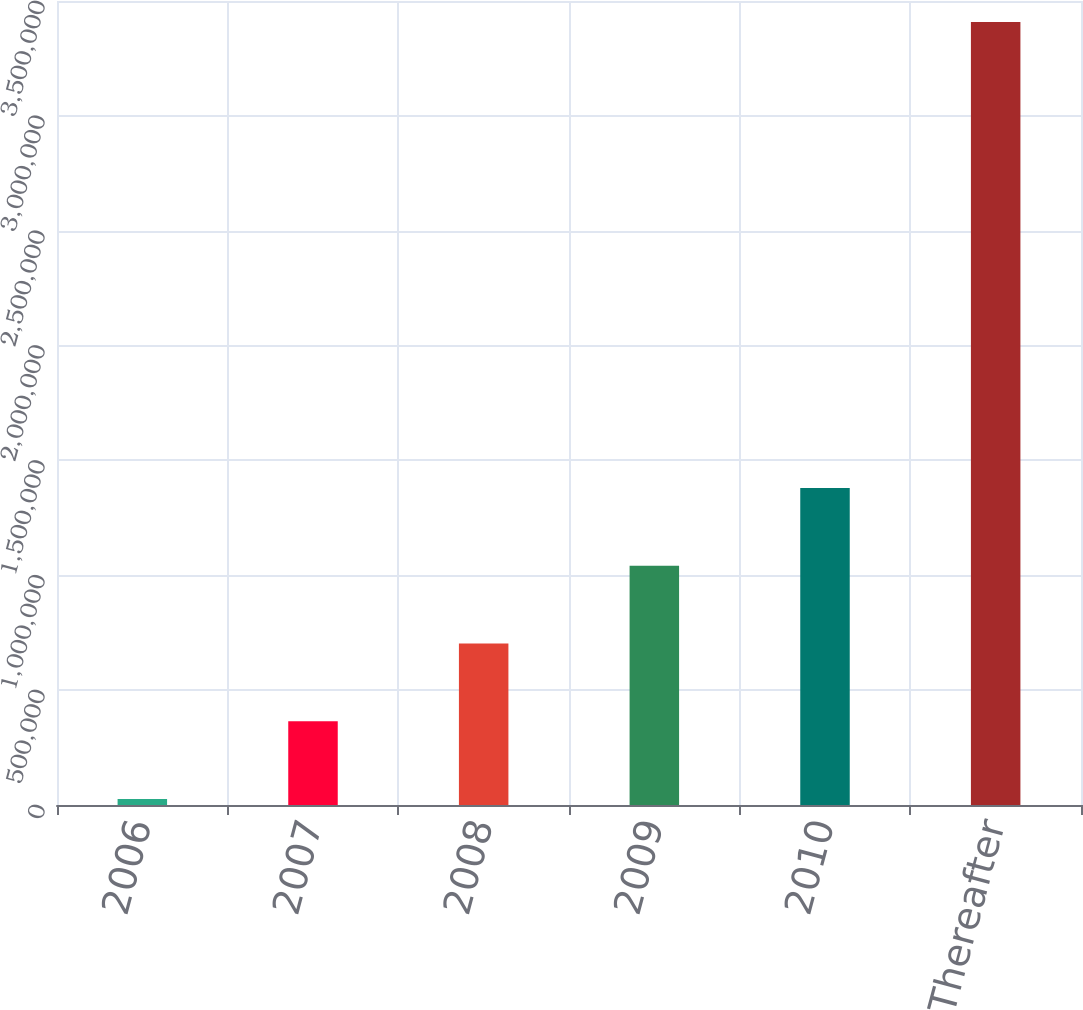Convert chart. <chart><loc_0><loc_0><loc_500><loc_500><bar_chart><fcel>2006<fcel>2007<fcel>2008<fcel>2009<fcel>2010<fcel>Thereafter<nl><fcel>26656<fcel>364854<fcel>703051<fcel>1.04125e+06<fcel>1.37945e+06<fcel>3.40863e+06<nl></chart> 